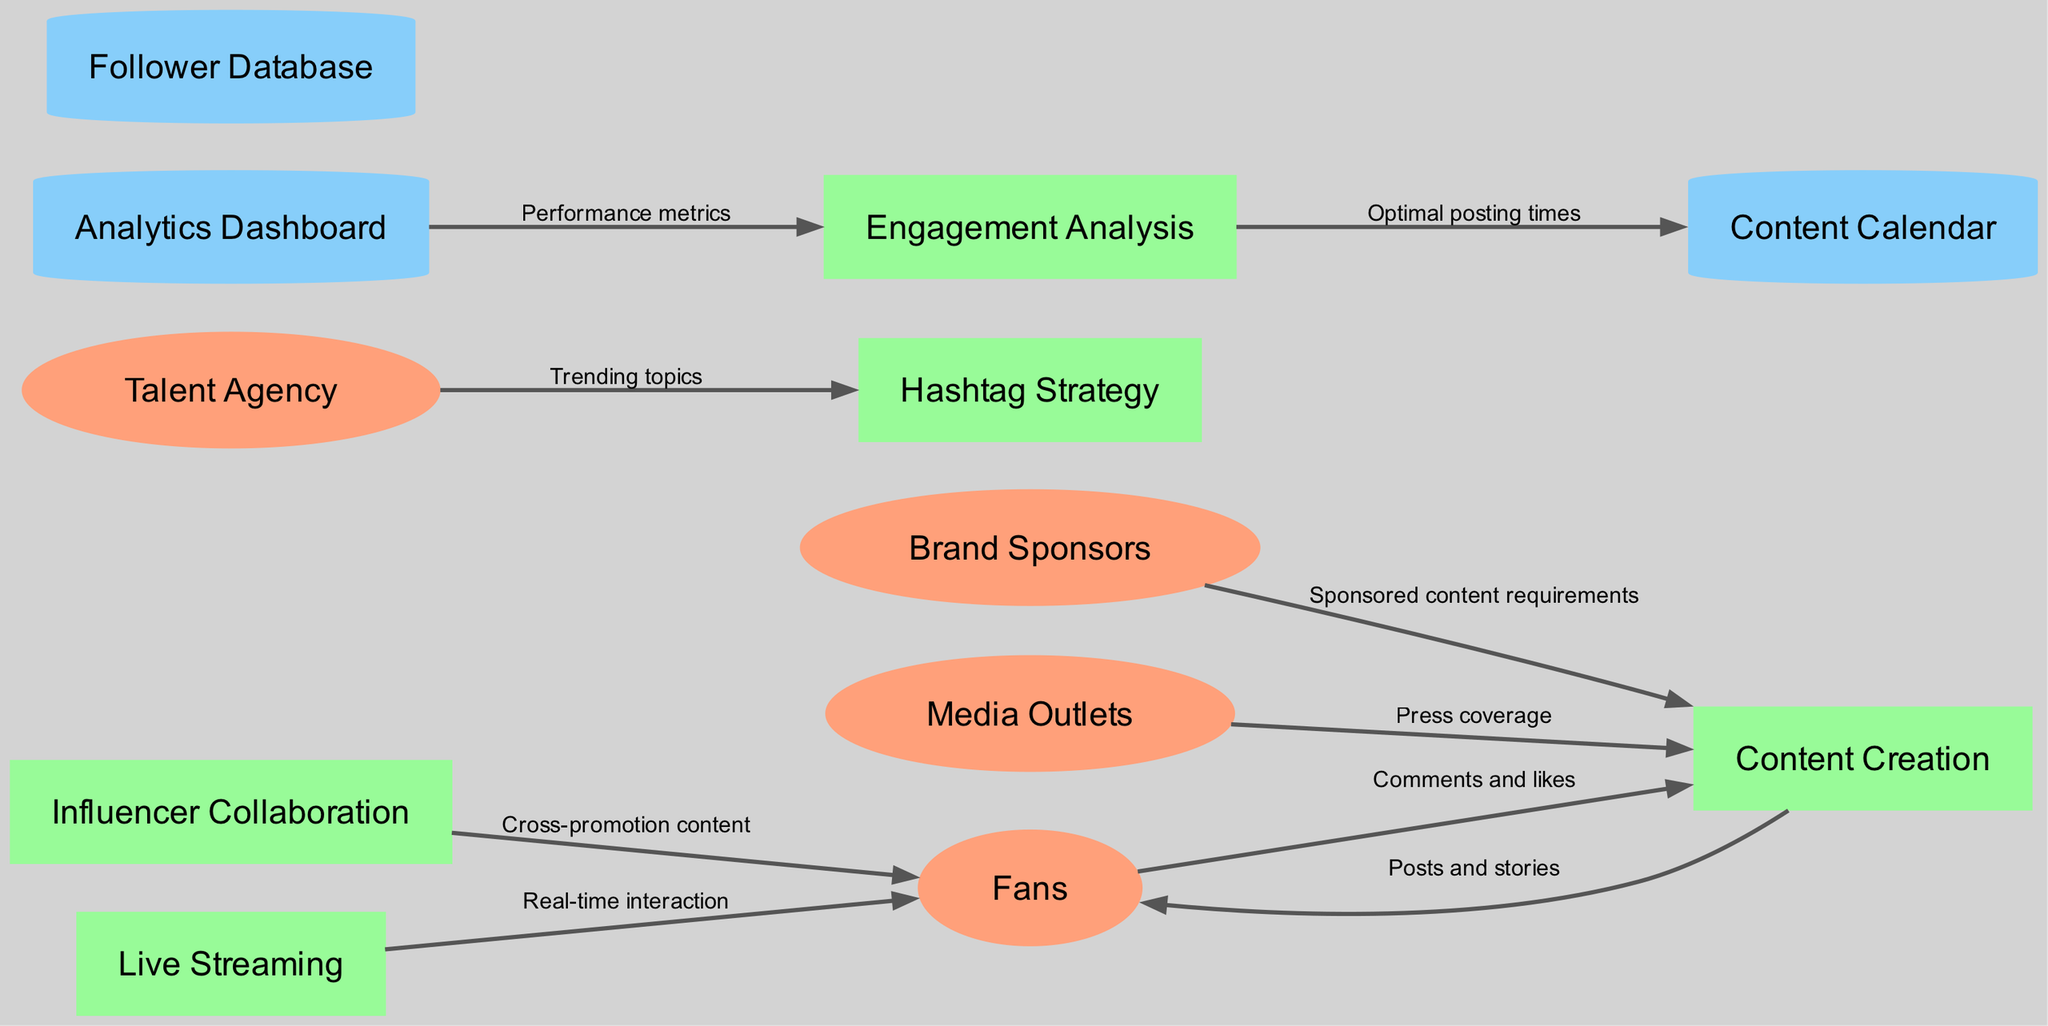What are the external entities in this diagram? The diagram lists four external entities: Fans, Talent Agency, Brand Sponsors, and Media Outlets. Each entity is represented as an ellipse in the diagram, making it identifiable as an external stakeholder in the social media engagement strategy.
Answer: Fans, Talent Agency, Brand Sponsors, Media Outlets How many processes are present in the diagram? There are five distinct processes shown in the diagram: Content Creation, Engagement Analysis, Hashtag Strategy, Influencer Collaboration, and Live Streaming. Each process is represented as a rectangle, indicating its function in the overall strategy.
Answer: 5 What type of data does the "Engagement Analysis" process receive from the "Analytics Dashboard"? The Engagement Analysis process receives performance metrics from the Analytics Dashboard. This flow is indicated by the labeled arrow connecting these two components, showing the input required for analyzing engagement.
Answer: Performance metrics Which external entity contributes sponsored content requirements to the Content Creation process? The Brand Sponsors external entity provides sponsored content requirements to the Content Creation process, as indicated by the directed flow labeled accordingly. This shows the influence of sponsorship on content strategy.
Answer: Brand Sponsors What is the relationship between the Talent Agency and the Hashtag Strategy process? The Talent Agency provides trending topics to the Hashtag Strategy process, facilitating a connection that helps in better targeting the audience through relevant hashtags. This relationship is depicted by a directed edge labeled "Trending topics."
Answer: Trending topics How do Fans interact with the Live Streaming process? Fans engage with the Live Streaming process through real-time interaction, which is represented by a flow directed from Live Streaming to Fans, indicating that fans can directly participate and respond during these events.
Answer: Real-time interaction Which process sends posts and stories to Fans? The Content Creation process sends posts and stories to Fans, according to the directed flow which connects these two components. This indicates the content dissemination effort aimed at engaging with followers.
Answer: Posts and stories What is the data store that holds optimal posting times? The optimal posting times are stored in the Content Calendar, as indicated by the flow from Engagement Analysis to Content Calendar, suggesting that engagement insights influence scheduling content.
Answer: Content Calendar Which external entity influences content creation through providing press coverage? Media Outlets influence content creation by providing press coverage, as shown in the diagram with a flow from Media Outlets to Content Creation. This indicates the role of media interactions in shaping the content strategy.
Answer: Media Outlets 